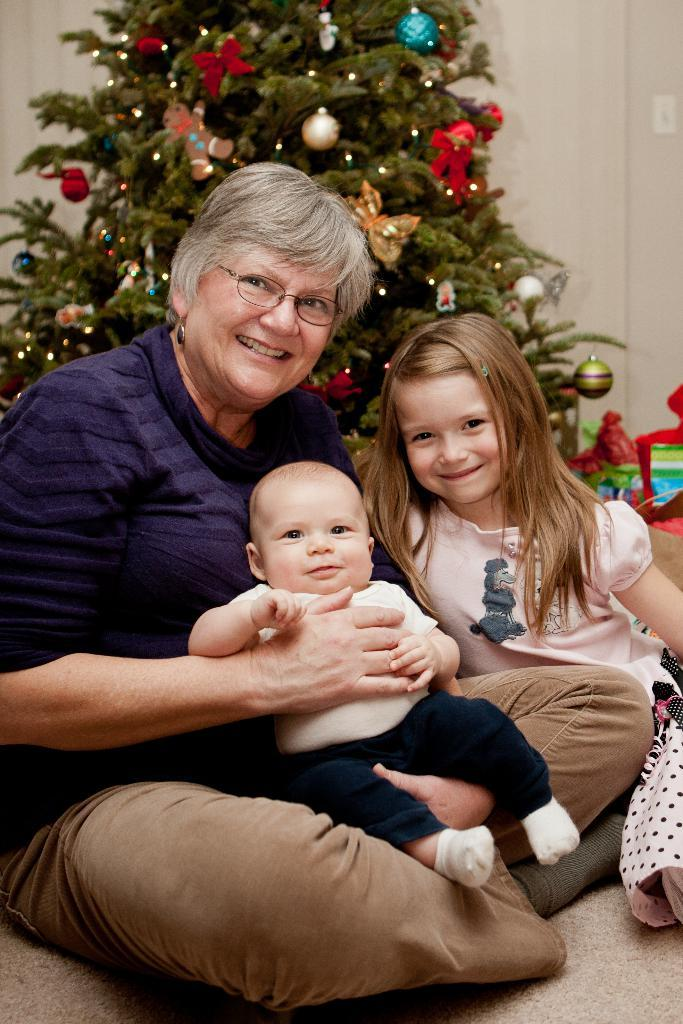Who is present in the image? There is a woman and two kids in the image. What is in the background of the image? There is a Christmas tree, lights, and decorative things visible in the background. What type of whip can be seen in the hands of the woman in the image? There is no whip present in the image; the woman is not holding any such object. 